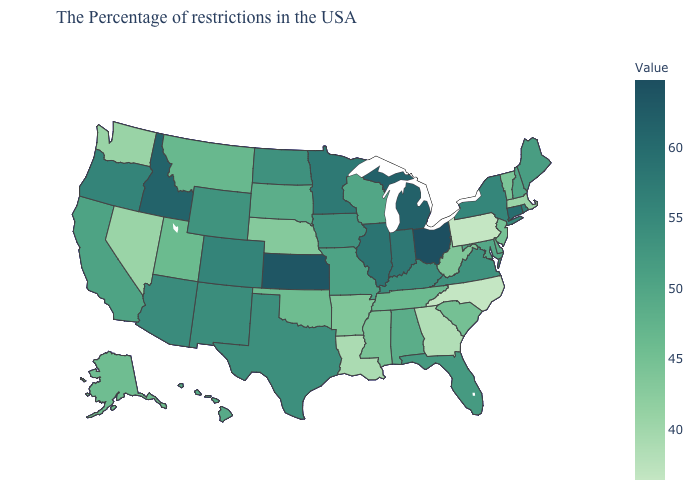Does Ohio have the highest value in the USA?
Answer briefly. Yes. Which states have the highest value in the USA?
Give a very brief answer. Ohio. Which states have the highest value in the USA?
Answer briefly. Ohio. Does the map have missing data?
Quick response, please. No. Among the states that border Georgia , which have the highest value?
Be succinct. Florida. Among the states that border Wyoming , which have the highest value?
Give a very brief answer. Idaho. 